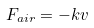Convert formula to latex. <formula><loc_0><loc_0><loc_500><loc_500>F _ { a i r } = - k v</formula> 